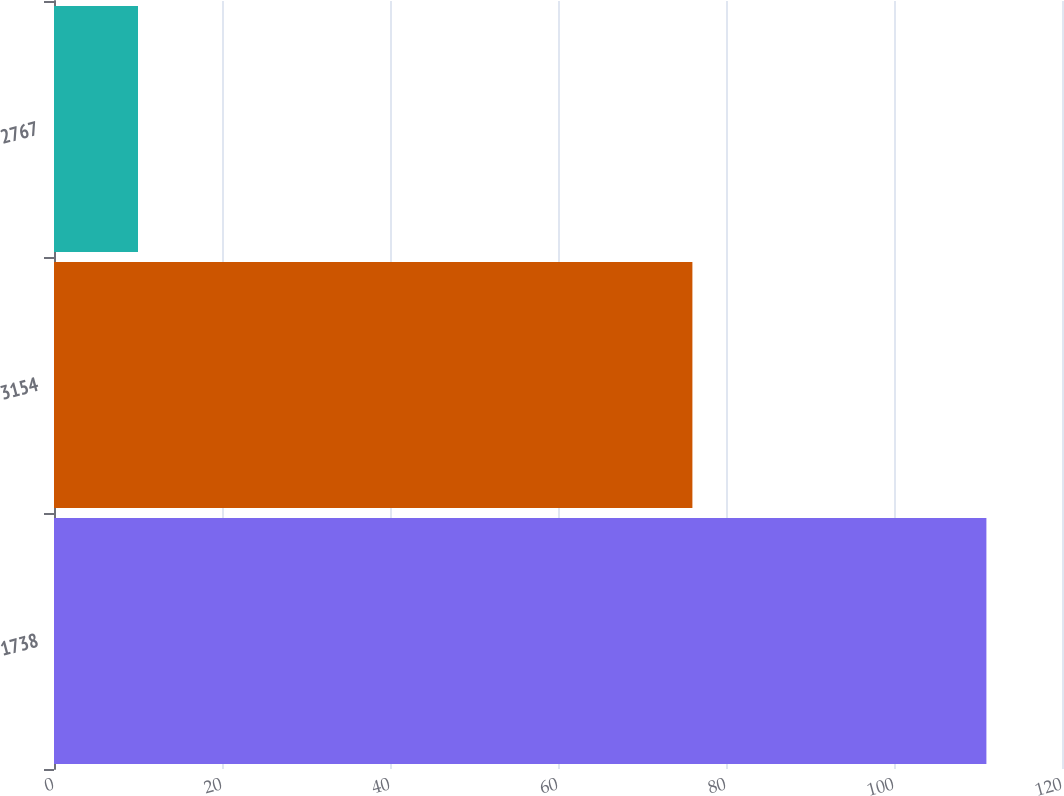<chart> <loc_0><loc_0><loc_500><loc_500><bar_chart><fcel>1738<fcel>3154<fcel>2767<nl><fcel>111<fcel>76<fcel>10<nl></chart> 